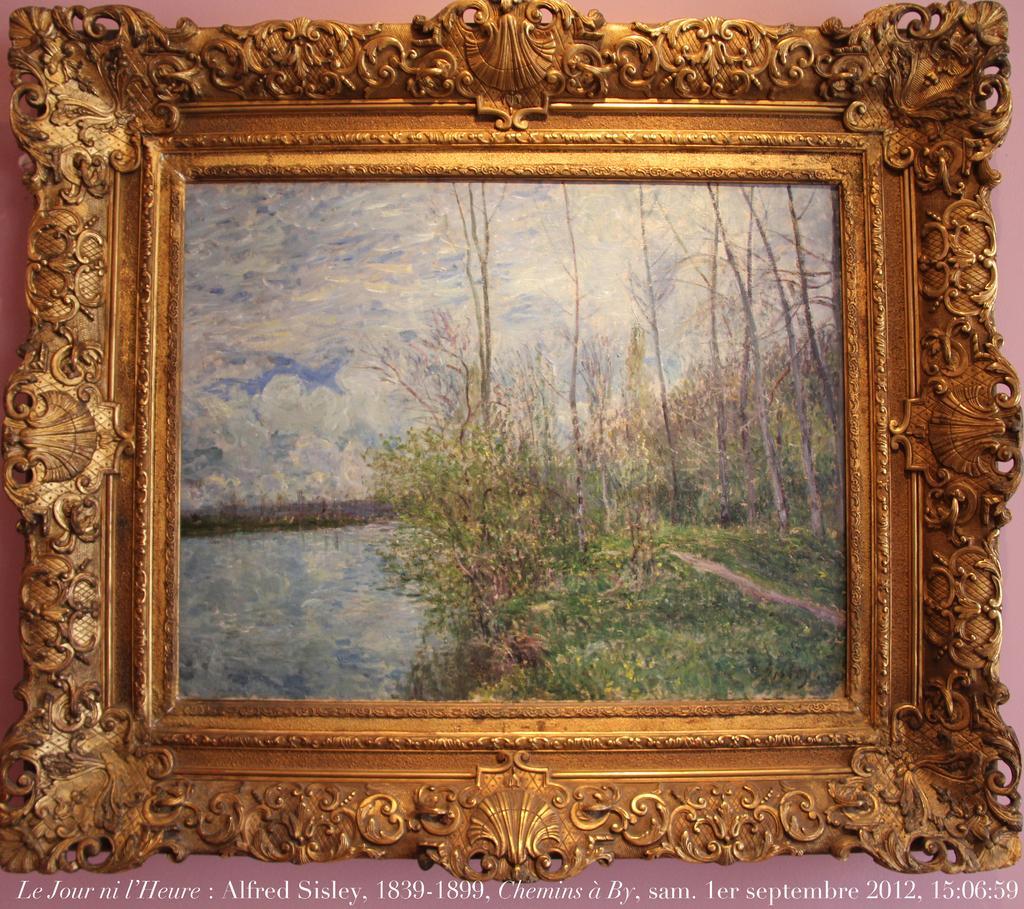Please provide a concise description of this image. We can see frame,on this frame we can see trees,water and sky. In the background it is pink. At the bottom of the image we can see text. 